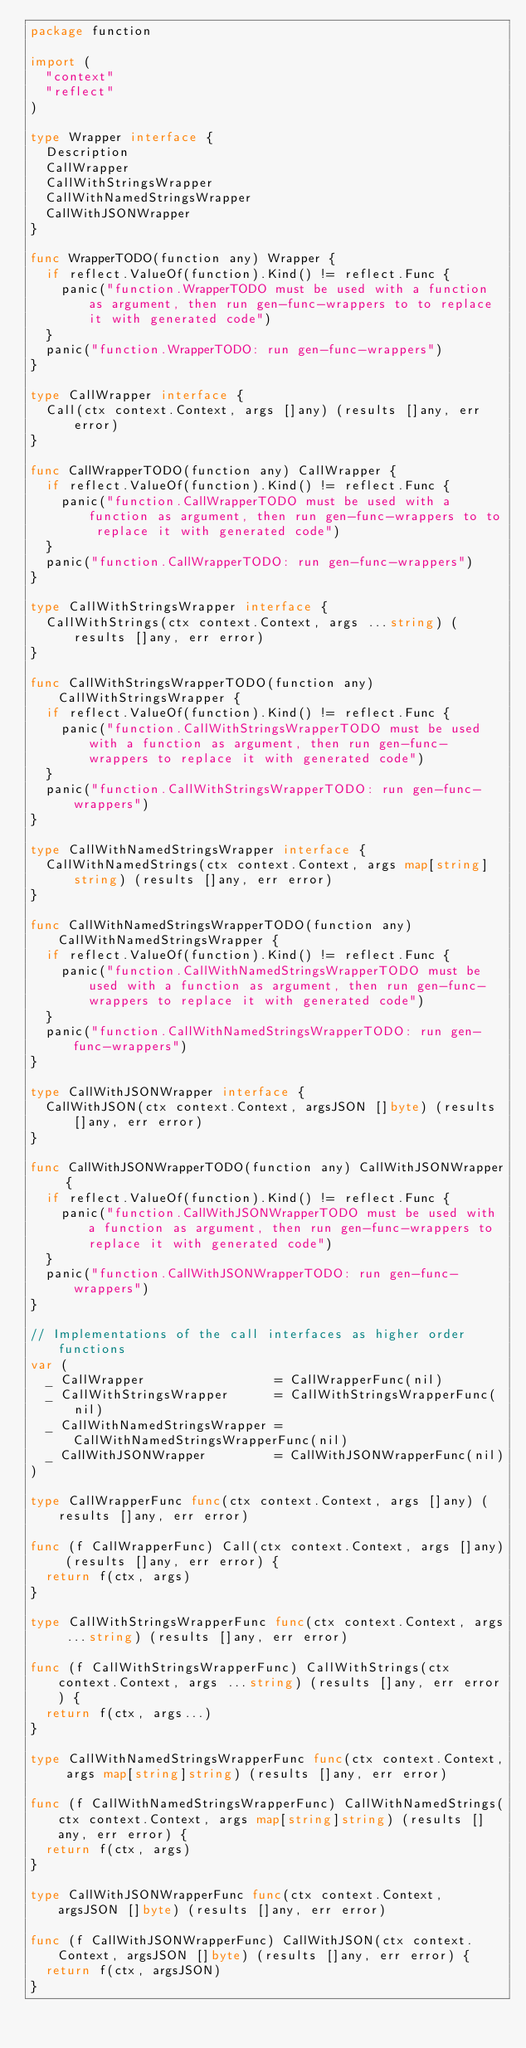Convert code to text. <code><loc_0><loc_0><loc_500><loc_500><_Go_>package function

import (
	"context"
	"reflect"
)

type Wrapper interface {
	Description
	CallWrapper
	CallWithStringsWrapper
	CallWithNamedStringsWrapper
	CallWithJSONWrapper
}

func WrapperTODO(function any) Wrapper {
	if reflect.ValueOf(function).Kind() != reflect.Func {
		panic("function.WrapperTODO must be used with a function as argument, then run gen-func-wrappers to to replace it with generated code")
	}
	panic("function.WrapperTODO: run gen-func-wrappers")
}

type CallWrapper interface {
	Call(ctx context.Context, args []any) (results []any, err error)
}

func CallWrapperTODO(function any) CallWrapper {
	if reflect.ValueOf(function).Kind() != reflect.Func {
		panic("function.CallWrapperTODO must be used with a function as argument, then run gen-func-wrappers to to replace it with generated code")
	}
	panic("function.CallWrapperTODO: run gen-func-wrappers")
}

type CallWithStringsWrapper interface {
	CallWithStrings(ctx context.Context, args ...string) (results []any, err error)
}

func CallWithStringsWrapperTODO(function any) CallWithStringsWrapper {
	if reflect.ValueOf(function).Kind() != reflect.Func {
		panic("function.CallWithStringsWrapperTODO must be used with a function as argument, then run gen-func-wrappers to replace it with generated code")
	}
	panic("function.CallWithStringsWrapperTODO: run gen-func-wrappers")
}

type CallWithNamedStringsWrapper interface {
	CallWithNamedStrings(ctx context.Context, args map[string]string) (results []any, err error)
}

func CallWithNamedStringsWrapperTODO(function any) CallWithNamedStringsWrapper {
	if reflect.ValueOf(function).Kind() != reflect.Func {
		panic("function.CallWithNamedStringsWrapperTODO must be used with a function as argument, then run gen-func-wrappers to replace it with generated code")
	}
	panic("function.CallWithNamedStringsWrapperTODO: run gen-func-wrappers")
}

type CallWithJSONWrapper interface {
	CallWithJSON(ctx context.Context, argsJSON []byte) (results []any, err error)
}

func CallWithJSONWrapperTODO(function any) CallWithJSONWrapper {
	if reflect.ValueOf(function).Kind() != reflect.Func {
		panic("function.CallWithJSONWrapperTODO must be used with a function as argument, then run gen-func-wrappers to replace it with generated code")
	}
	panic("function.CallWithJSONWrapperTODO: run gen-func-wrappers")
}

// Implementations of the call interfaces as higher order functions
var (
	_ CallWrapper                 = CallWrapperFunc(nil)
	_ CallWithStringsWrapper      = CallWithStringsWrapperFunc(nil)
	_ CallWithNamedStringsWrapper = CallWithNamedStringsWrapperFunc(nil)
	_ CallWithJSONWrapper         = CallWithJSONWrapperFunc(nil)
)

type CallWrapperFunc func(ctx context.Context, args []any) (results []any, err error)

func (f CallWrapperFunc) Call(ctx context.Context, args []any) (results []any, err error) {
	return f(ctx, args)
}

type CallWithStringsWrapperFunc func(ctx context.Context, args ...string) (results []any, err error)

func (f CallWithStringsWrapperFunc) CallWithStrings(ctx context.Context, args ...string) (results []any, err error) {
	return f(ctx, args...)
}

type CallWithNamedStringsWrapperFunc func(ctx context.Context, args map[string]string) (results []any, err error)

func (f CallWithNamedStringsWrapperFunc) CallWithNamedStrings(ctx context.Context, args map[string]string) (results []any, err error) {
	return f(ctx, args)
}

type CallWithJSONWrapperFunc func(ctx context.Context, argsJSON []byte) (results []any, err error)

func (f CallWithJSONWrapperFunc) CallWithJSON(ctx context.Context, argsJSON []byte) (results []any, err error) {
	return f(ctx, argsJSON)
}
</code> 